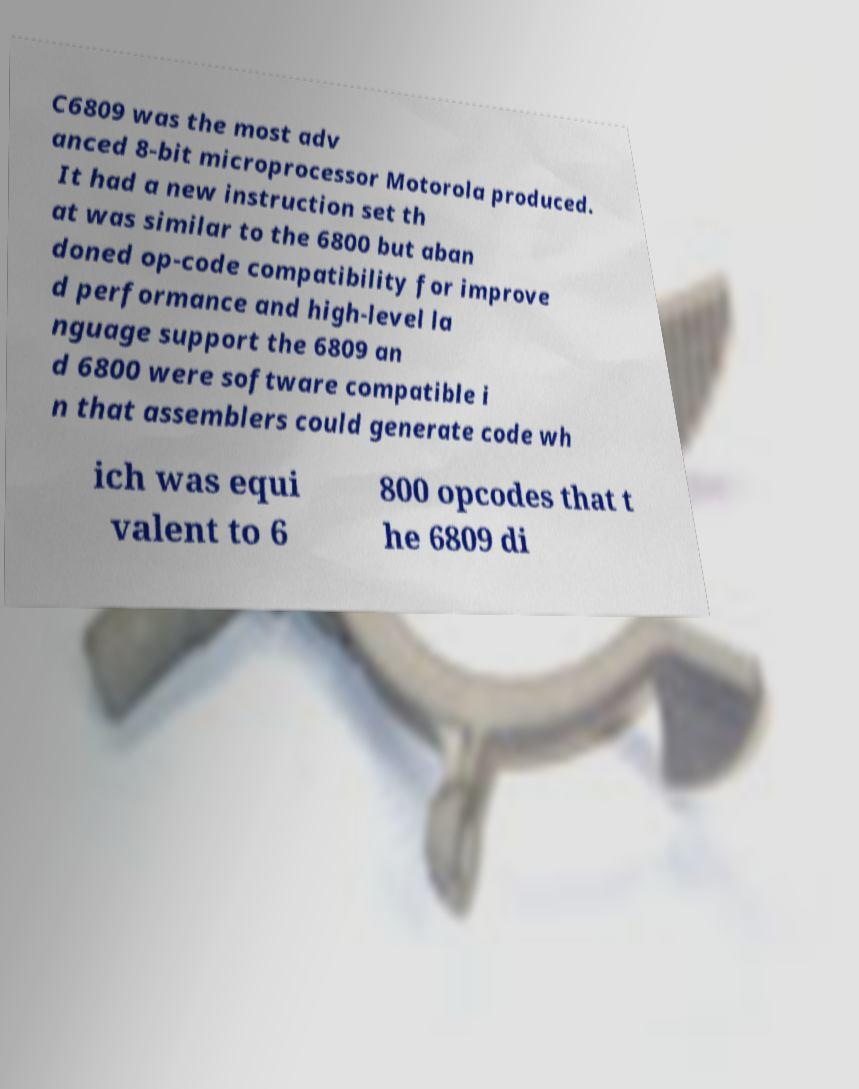I need the written content from this picture converted into text. Can you do that? C6809 was the most adv anced 8-bit microprocessor Motorola produced. It had a new instruction set th at was similar to the 6800 but aban doned op-code compatibility for improve d performance and high-level la nguage support the 6809 an d 6800 were software compatible i n that assemblers could generate code wh ich was equi valent to 6 800 opcodes that t he 6809 di 